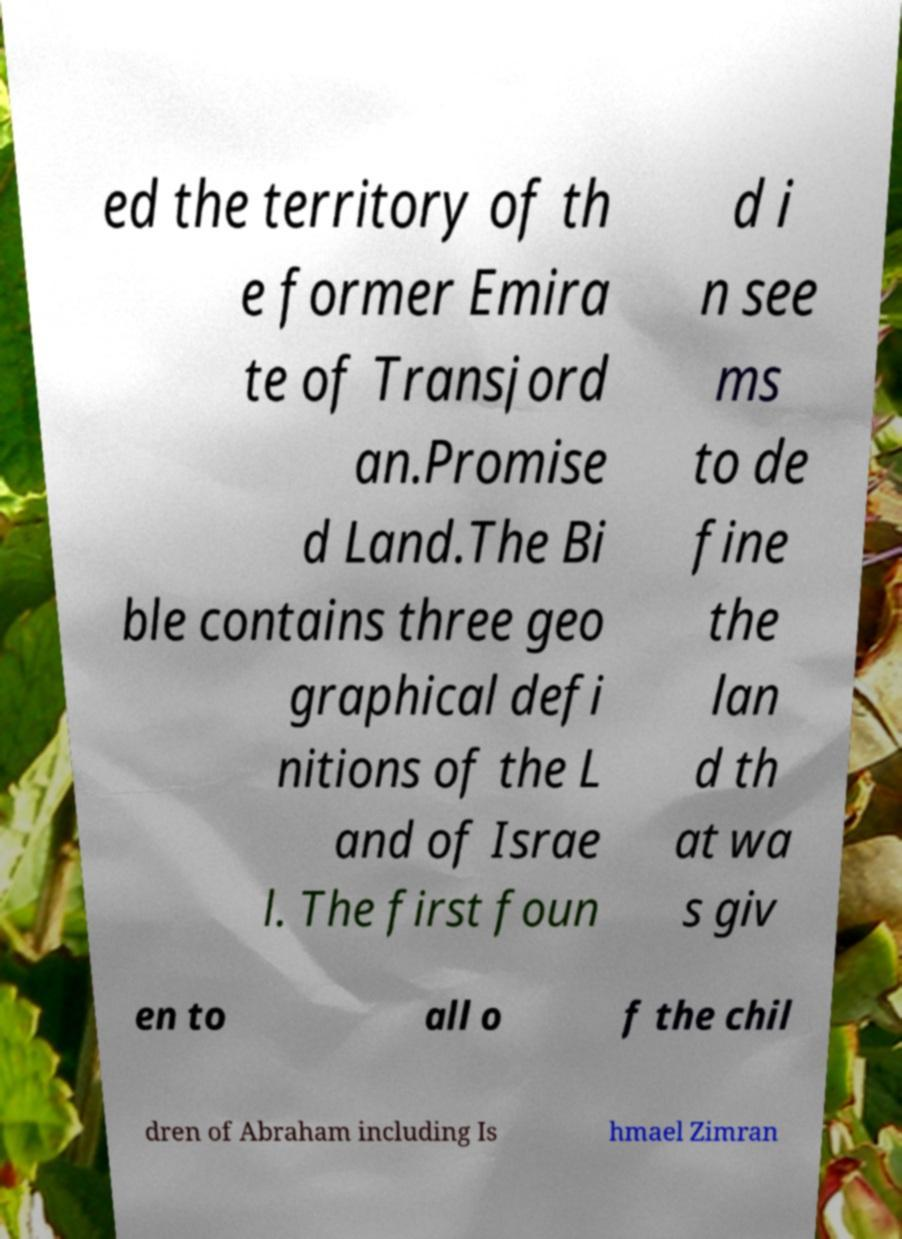For documentation purposes, I need the text within this image transcribed. Could you provide that? ed the territory of th e former Emira te of Transjord an.Promise d Land.The Bi ble contains three geo graphical defi nitions of the L and of Israe l. The first foun d i n see ms to de fine the lan d th at wa s giv en to all o f the chil dren of Abraham including Is hmael Zimran 